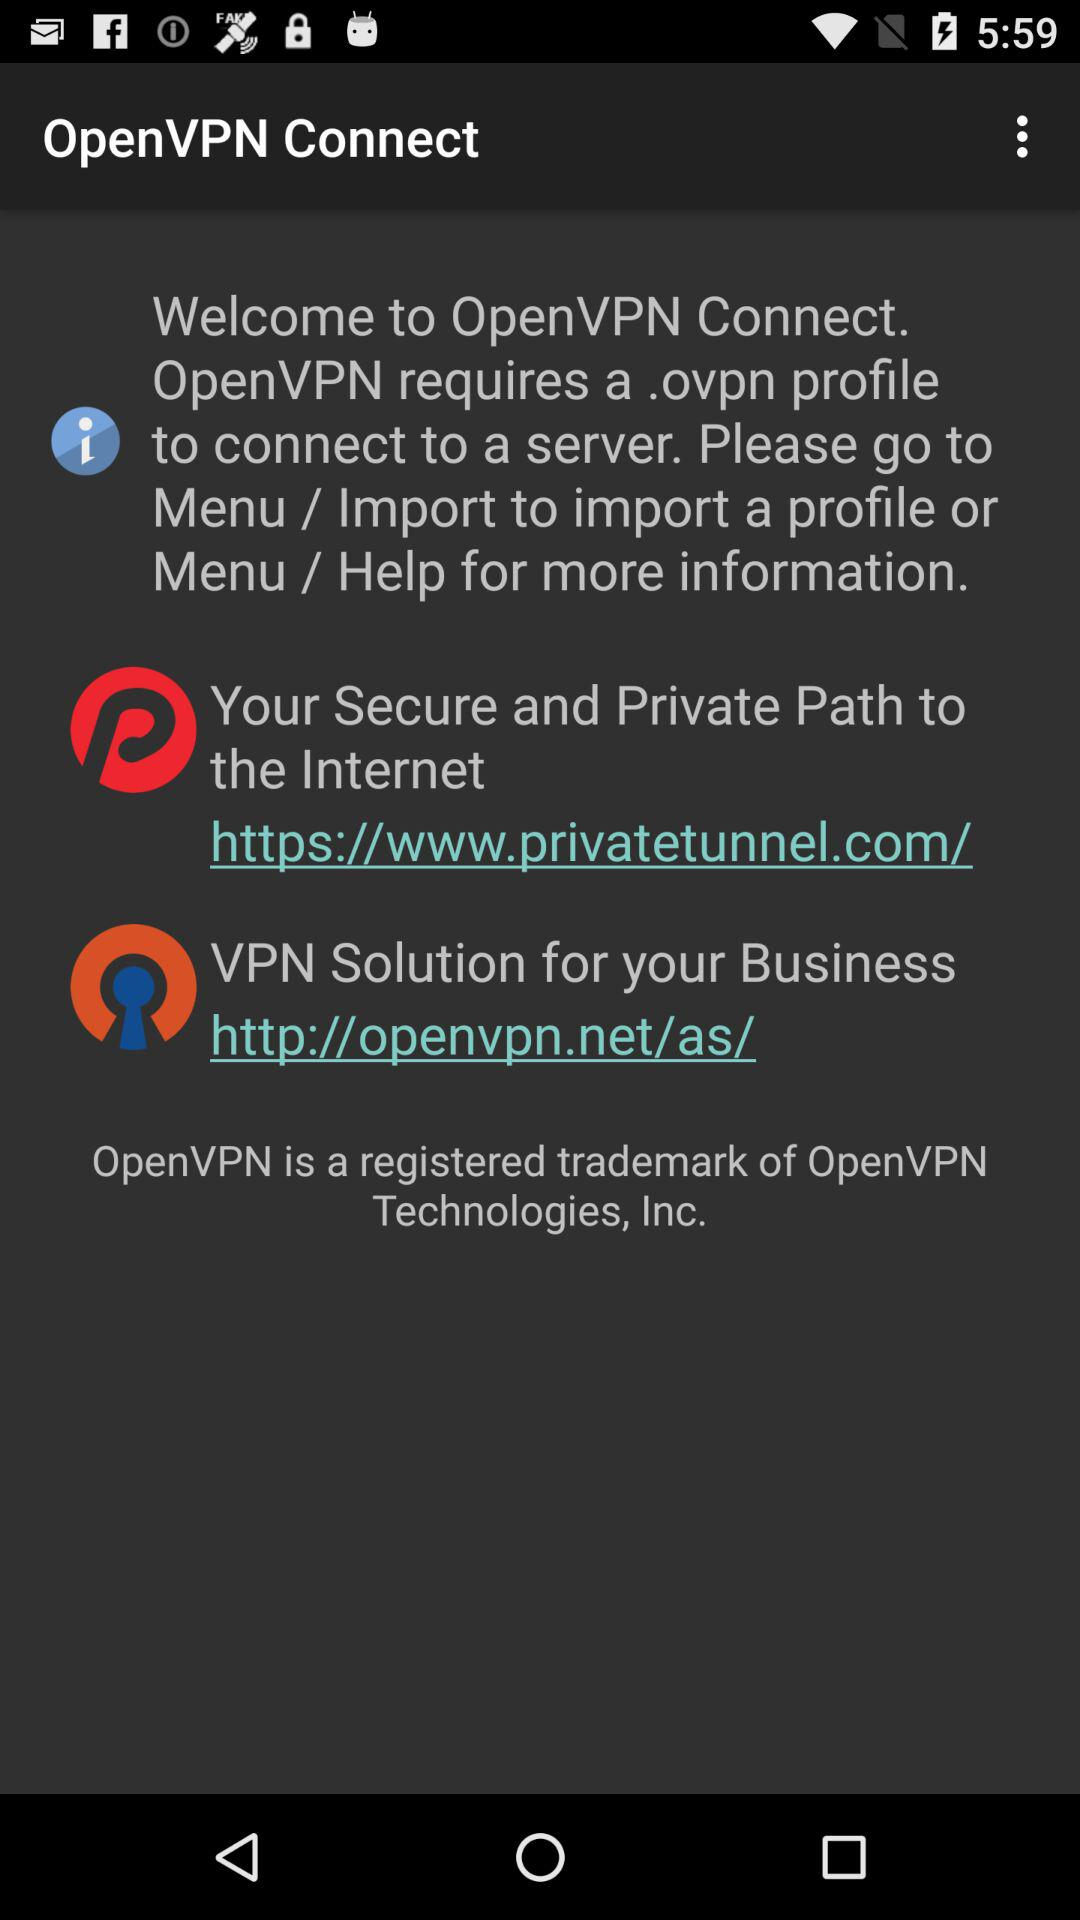What kind of profile require to connect to a server? The profile required to connect to a server is ".ovpn". 